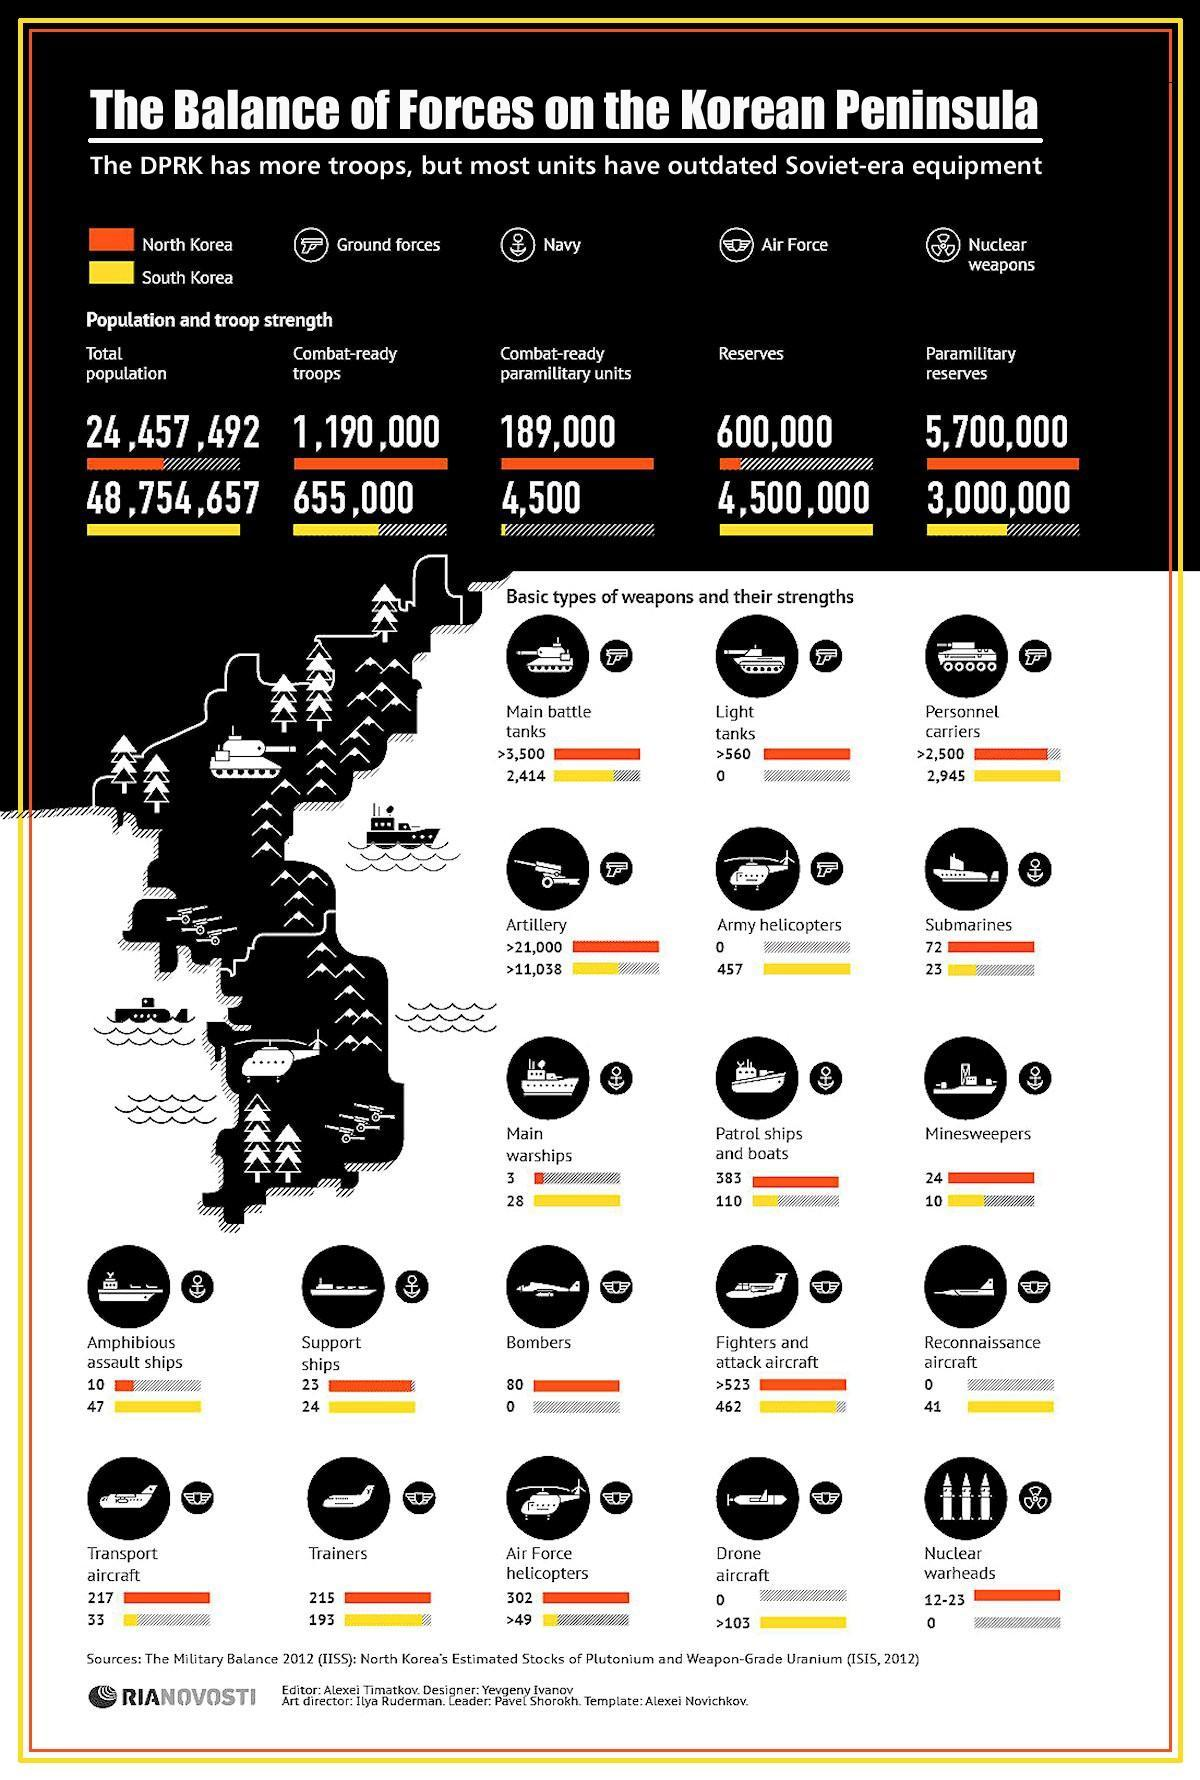comparison  of how many navy resources are given in this infographic?
Answer the question with a short phrase. 6 which country among North Korea and South Korea has higher population? North Korea how many army helicopters do South Korea own? 457 which country has more light tanks? North Korea comparison of how many air force resources are given in this infographic? 7 how many submarines do North Korea own? 72 how many Reconnaissance aircrafts South Korea own? 41 which country among North Korea and South Korea has more war ships? South Korea what is the total number of transport aircrafts and bombers owned by North Korea? 297 which country has more number of nuclear weapons? North korea how many Patrol ships and boats North Korea own? 383 which country among North Korea and South Korea has more minesweepers? North Korea which country among North Korea and South Korea has more paramilitary reserves? South Korea 